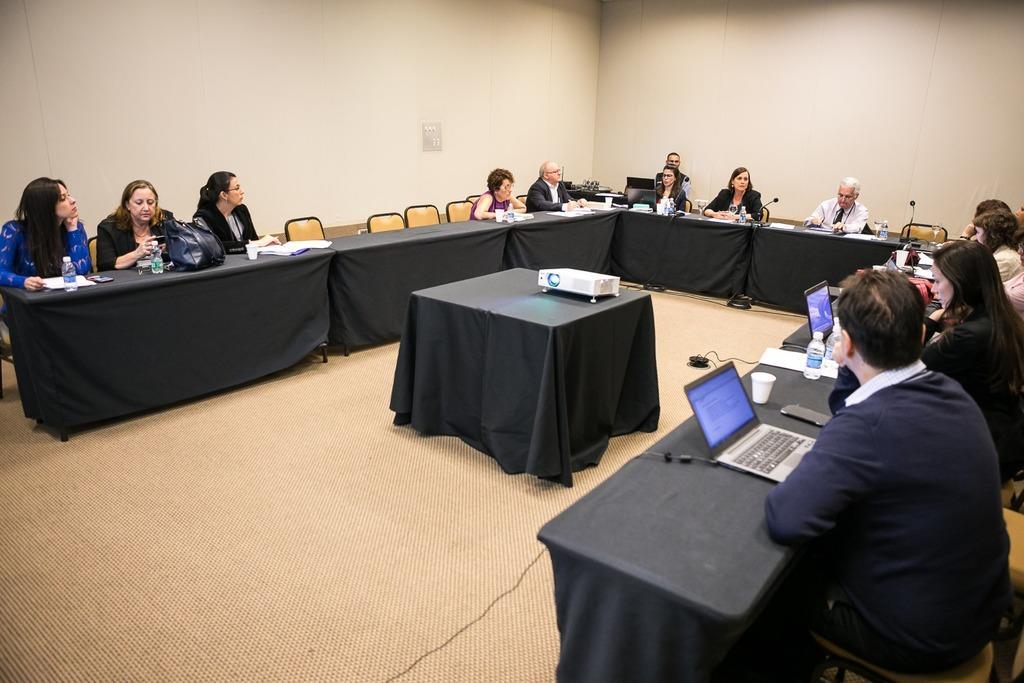How would you summarize this image in a sentence or two? In this picture we can see a group of people sitting on chair and in front of them there is table and on table we can see bottle, bag, papers, mic, laptop, glass, mobile and in middle there is a projector on table and in background we can see wall. 